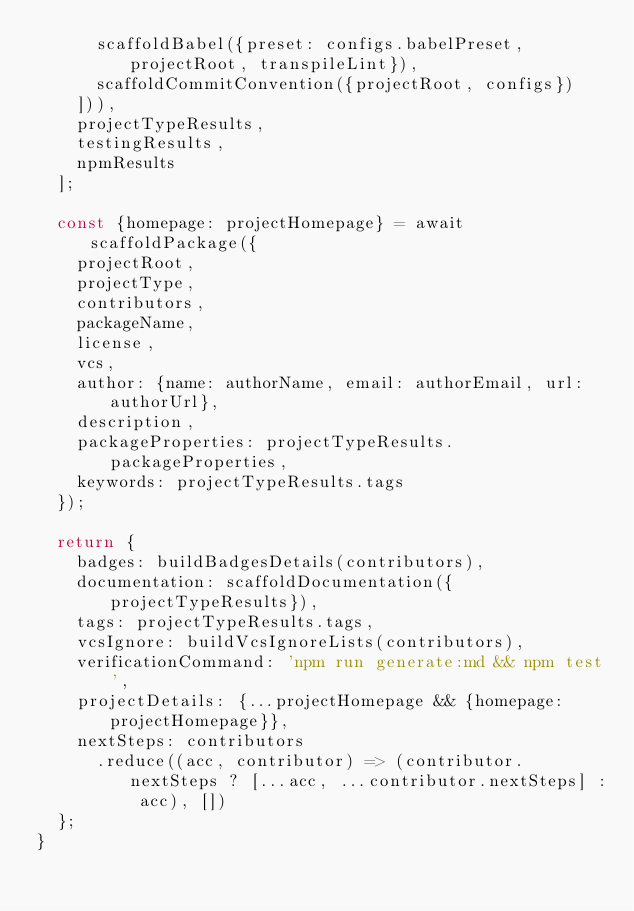<code> <loc_0><loc_0><loc_500><loc_500><_JavaScript_>      scaffoldBabel({preset: configs.babelPreset, projectRoot, transpileLint}),
      scaffoldCommitConvention({projectRoot, configs})
    ])),
    projectTypeResults,
    testingResults,
    npmResults
  ];

  const {homepage: projectHomepage} = await scaffoldPackage({
    projectRoot,
    projectType,
    contributors,
    packageName,
    license,
    vcs,
    author: {name: authorName, email: authorEmail, url: authorUrl},
    description,
    packageProperties: projectTypeResults.packageProperties,
    keywords: projectTypeResults.tags
  });

  return {
    badges: buildBadgesDetails(contributors),
    documentation: scaffoldDocumentation({projectTypeResults}),
    tags: projectTypeResults.tags,
    vcsIgnore: buildVcsIgnoreLists(contributors),
    verificationCommand: 'npm run generate:md && npm test',
    projectDetails: {...projectHomepage && {homepage: projectHomepage}},
    nextSteps: contributors
      .reduce((acc, contributor) => (contributor.nextSteps ? [...acc, ...contributor.nextSteps] : acc), [])
  };
}
</code> 